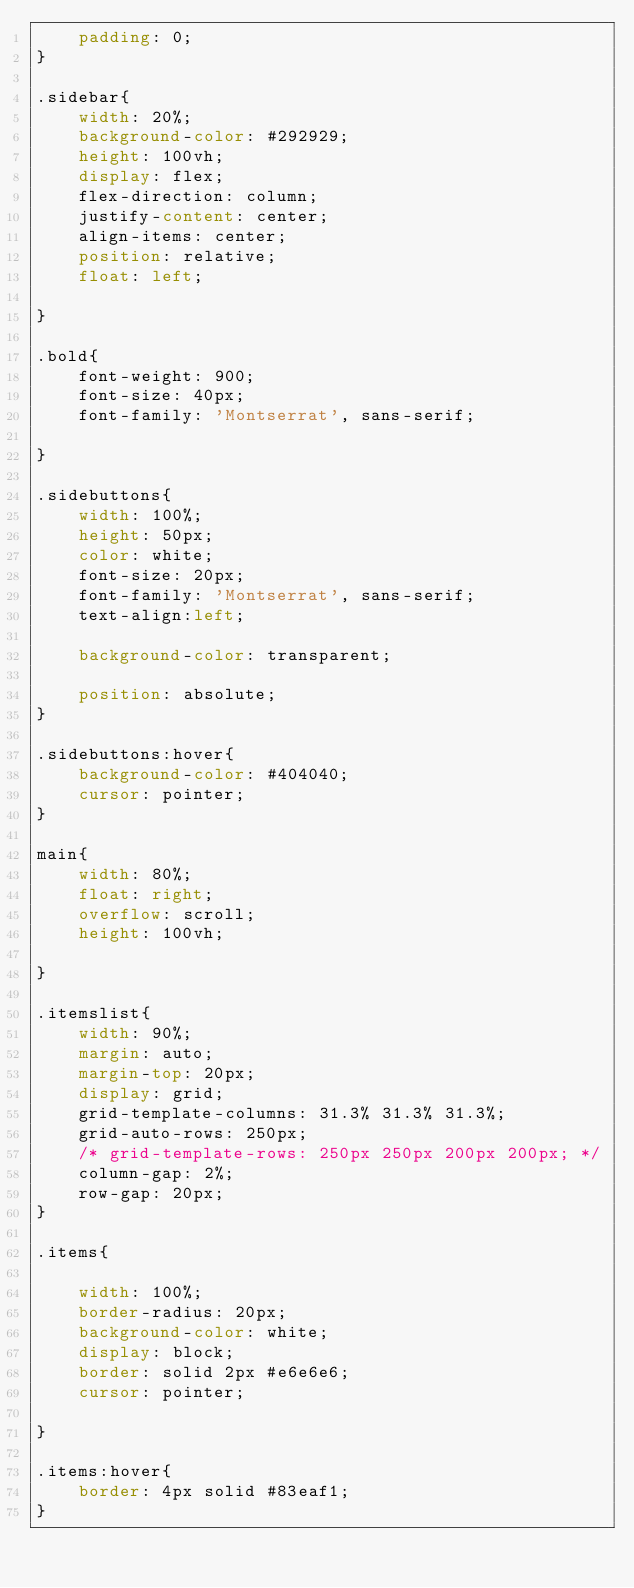<code> <loc_0><loc_0><loc_500><loc_500><_CSS_>    padding: 0;
}

.sidebar{
    width: 20%;
    background-color: #292929;
    height: 100vh;
    display: flex;
    flex-direction: column;
    justify-content: center;
    align-items: center;
    position: relative;
    float: left;
    
}

.bold{
    font-weight: 900;
    font-size: 40px;
    font-family: 'Montserrat', sans-serif;

}

.sidebuttons{
    width: 100%; 
    height: 50px; 
    color: white;
    font-size: 20px;
    font-family: 'Montserrat', sans-serif;
    text-align:left;

    background-color: transparent;
    
    position: absolute;
}

.sidebuttons:hover{
    background-color: #404040;
    cursor: pointer;
}

main{
    width: 80%;
    float: right;
    overflow: scroll;
    height: 100vh;

}

.itemslist{
    width: 90%;
    margin: auto;
    margin-top: 20px;
    display: grid;
    grid-template-columns: 31.3% 31.3% 31.3%;
    grid-auto-rows: 250px;
    /* grid-template-rows: 250px 250px 200px 200px; */
    column-gap: 2%;
    row-gap: 20px;
}

.items{
  
    width: 100%;
    border-radius: 20px;
    background-color: white;
    display: block;
    border: solid 2px #e6e6e6;
    cursor: pointer;
    
}

.items:hover{
    border: 4px solid #83eaf1;
}
</code> 